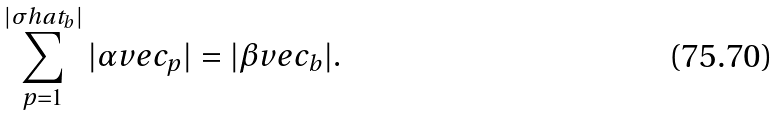<formula> <loc_0><loc_0><loc_500><loc_500>\sum _ { p = 1 } ^ { | \sigma h a t _ { b } | } | \alpha v e c _ { p } | = | \beta v e c _ { b } | .</formula> 